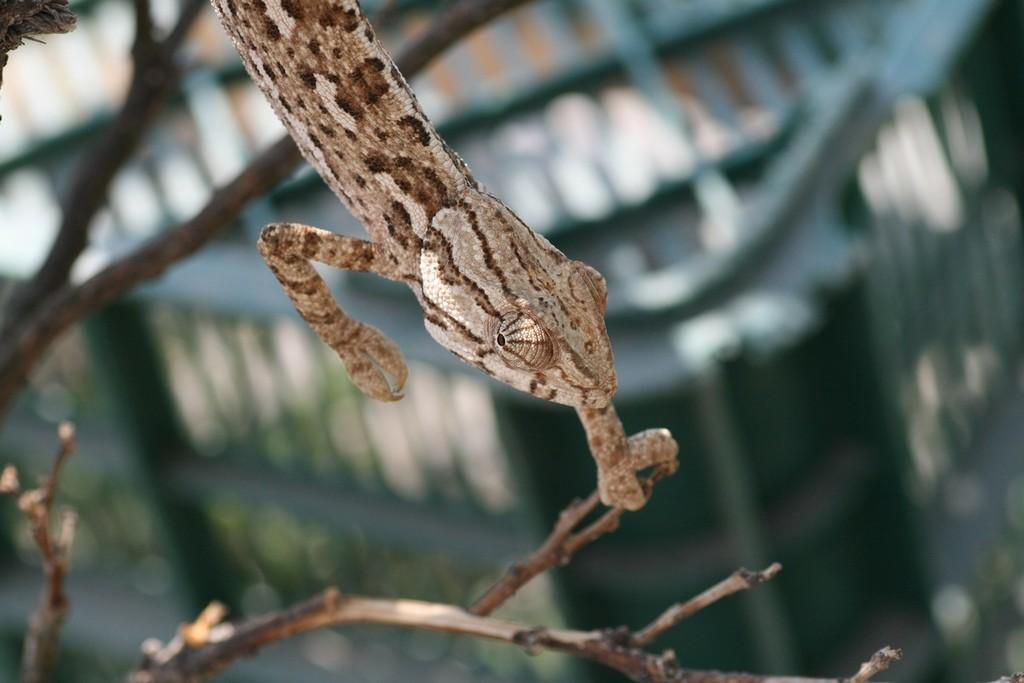What type of animal is in the image? There is a reptile in the image. Where is the reptile located? The reptile is on the branches of a tree. Can you describe the background of the image? The background of the image is blurry. What else can be seen in the background? There are other objects visible in the background. What type of breakfast is the reptile eating in the image? There is no breakfast present in the image, as it features a reptile on the branches of a tree. 